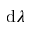Convert formula to latex. <formula><loc_0><loc_0><loc_500><loc_500>d \lambda</formula> 